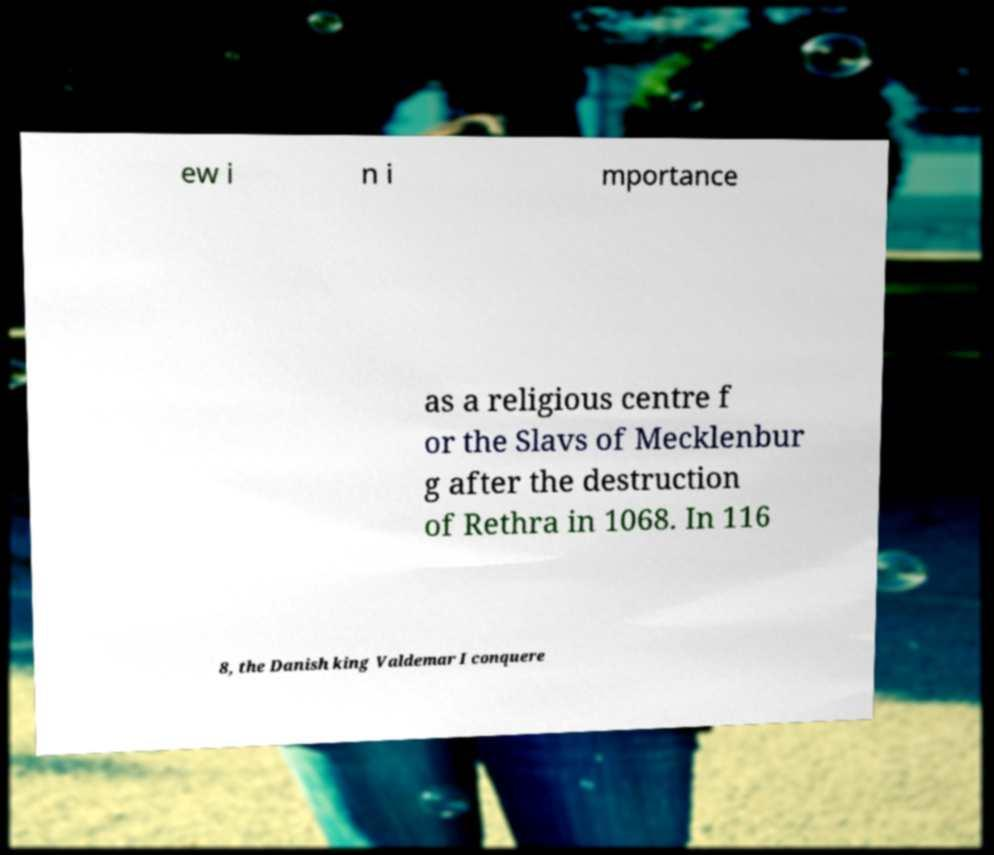What messages or text are displayed in this image? I need them in a readable, typed format. ew i n i mportance as a religious centre f or the Slavs of Mecklenbur g after the destruction of Rethra in 1068. In 116 8, the Danish king Valdemar I conquere 